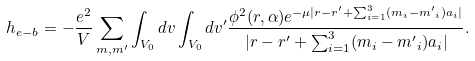Convert formula to latex. <formula><loc_0><loc_0><loc_500><loc_500>h _ { e - b } = - \frac { e ^ { 2 } } { V } \sum _ { m , m ^ { \prime } } \int _ { V _ { 0 } } d v \int _ { V _ { 0 } } d v ^ { \prime } \frac { { \phi } ^ { 2 } ( r , \alpha ) e ^ { - \mu | r - r ^ { \prime } + \sum _ { i = 1 } ^ { 3 } ( m _ { i } - { m ^ { \prime } } _ { i } ) a _ { i } | } } { | r - r ^ { \prime } + \sum _ { i = 1 } ^ { 3 } ( m _ { i } - { m ^ { \prime } } _ { i } ) a _ { i } | } .</formula> 